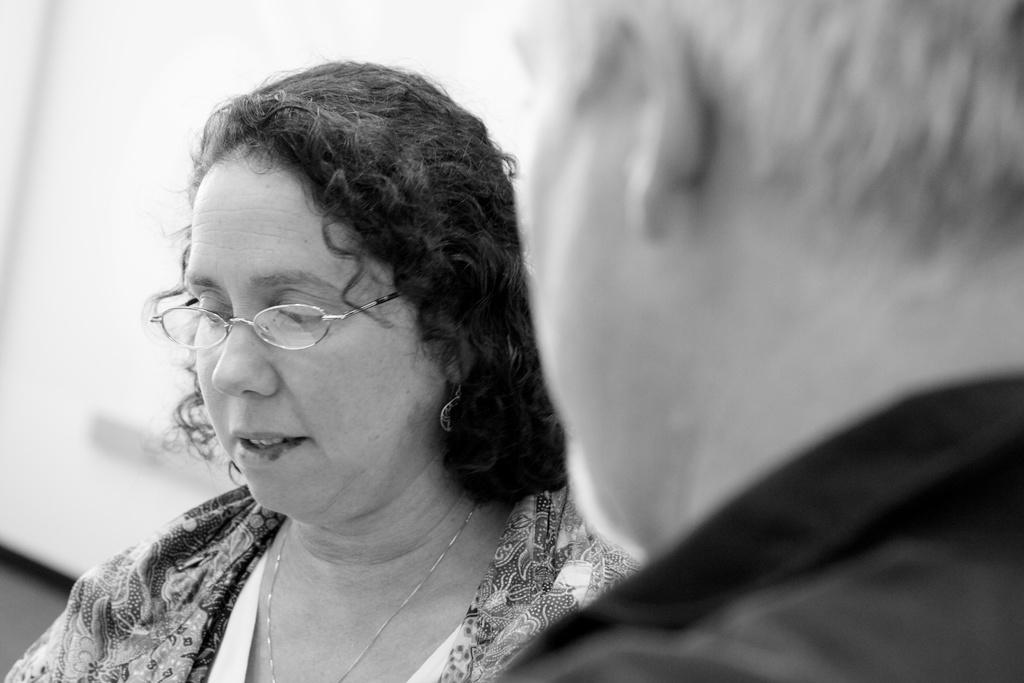What is the color scheme of the image? The image is black and white. Can you describe the people in the image? There is a man and a woman in the image. What type of zinc is being used by the laborer in the image? There is no laborer or zinc present in the image. When is the recess taking place in the image? There is no indication of a recess or any specific time in the image. 